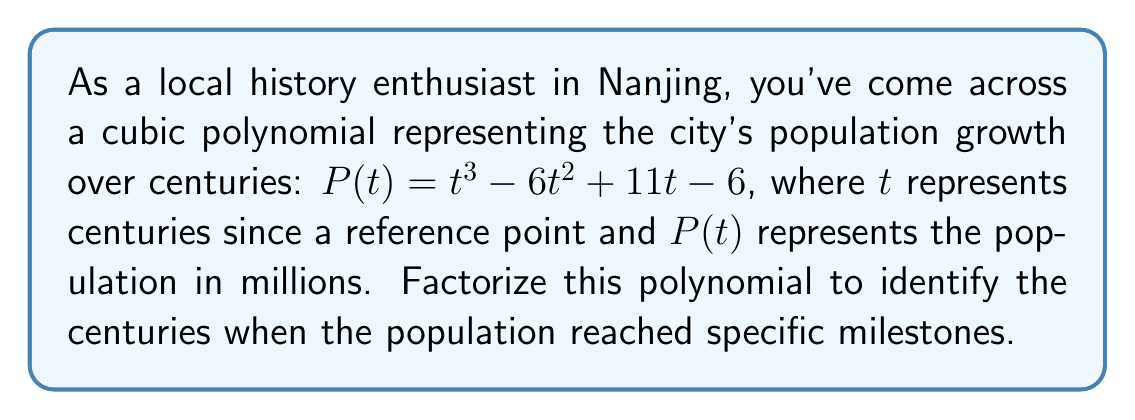Can you answer this question? To factorize the cubic polynomial $P(t) = t^3 - 6t^2 + 11t - 6$, we'll follow these steps:

1) First, let's check if there's a rational root. We can use the rational root theorem, which states that if a polynomial equation has integer coefficients, then any rational solution, when reduced to lowest terms, will have a numerator that divides the constant term and a denominator that divides the leading coefficient.

   Possible rational roots: $\pm 1, \pm 2, \pm 3, \pm 6$

2) By testing these values, we find that $t = 1$ is a root of the polynomial.

3) Now we can factor out $(t - 1)$:

   $P(t) = (t - 1)(t^2 - 5t + 6)$

4) The quadratic factor $t^2 - 5t + 6$ can be factored further using the quadratic formula or by inspection. In this case, we can see that it factors as:

   $(t - 2)(t - 3)$

5) Therefore, the complete factorization is:

   $P(t) = (t - 1)(t - 2)(t - 3)$

This factorization tells us that the population reached specific milestones at 1, 2, and 3 centuries after the reference point.
Answer: $P(t) = (t - 1)(t - 2)(t - 3)$ 